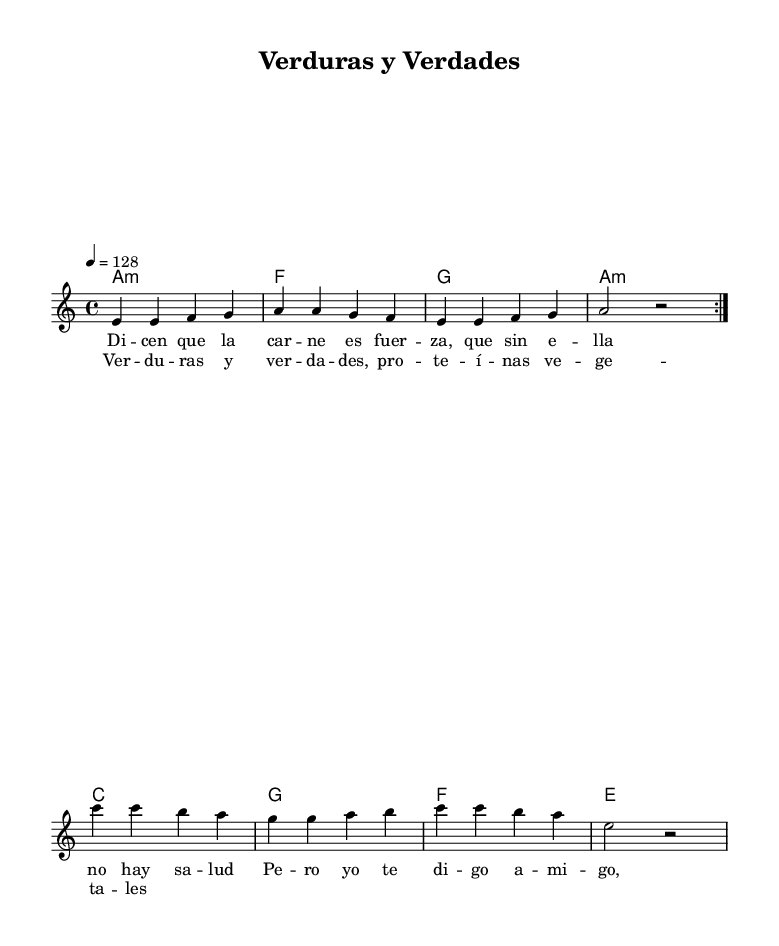What is the key signature of this music? The key signature is A minor, which contains no sharps or flats.
Answer: A minor What is the time signature of the music? The time signature is indicated at the beginning of the score and is 4/4, meaning there are four beats per measure.
Answer: 4/4 What is the tempo marking of this piece? The tempo marking is provided in the score, showing that the tempo should be played at 128 beats per minute.
Answer: 128 How many measures are in the melody section? The melody section includes two repeated sections, each containing four measures, so there are a total of eight measures.
Answer: 8 What chords are played during the chorus? The chord sequence in the chorus is derived from the harmonies provided in the score, including A minor, F major, G major, and A minor again.
Answer: A minor, F, G, A minor What is the primary thematic focus of the lyrics? The lyrics discuss the misconception about meat being essential for strength and promote the idea of plant-based protein as an alternative.
Answer: Plant-based protein What genre does this piece belong to? The genre is identified through the stylistic elements, rhythm, and cultural context, which are characteristic of Bachata music.
Answer: Bachata 